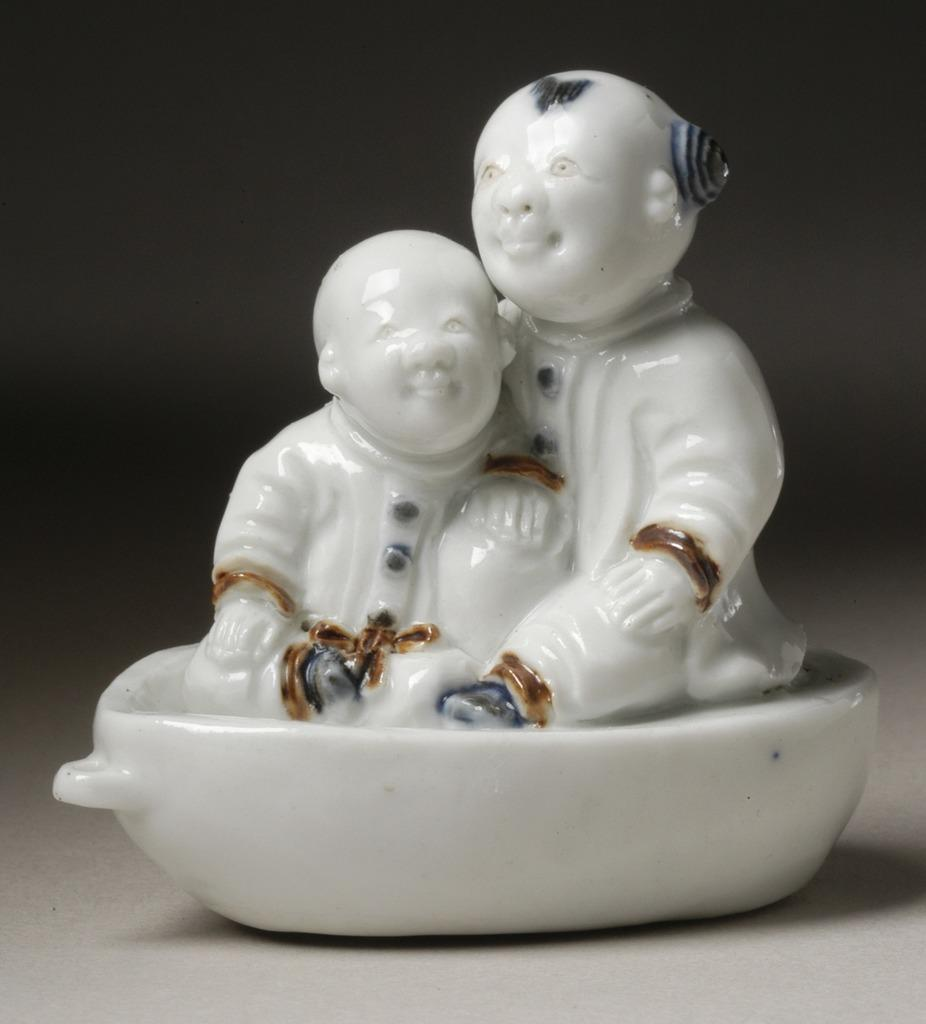What object can be seen in the image? There is a toy in the image. Where is the toy located? The toy is on a platform. What can be observed about the background of the image? The background of the image is dark. What type of army can be seen marching in the image? There is no army present in the image; it features a toy on a platform with a dark background. Is there a trail visible in the image? There is no trail visible in the image; it only shows a toy on a platform with a dark background. 